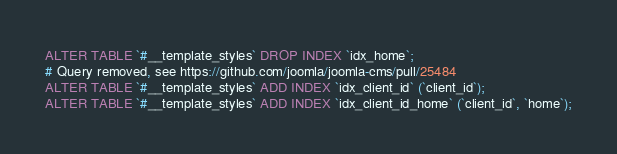Convert code to text. <code><loc_0><loc_0><loc_500><loc_500><_SQL_>ALTER TABLE `#__template_styles` DROP INDEX `idx_home`;
# Query removed, see https://github.com/joomla/joomla-cms/pull/25484
ALTER TABLE `#__template_styles` ADD INDEX `idx_client_id` (`client_id`);
ALTER TABLE `#__template_styles` ADD INDEX `idx_client_id_home` (`client_id`, `home`);
</code> 